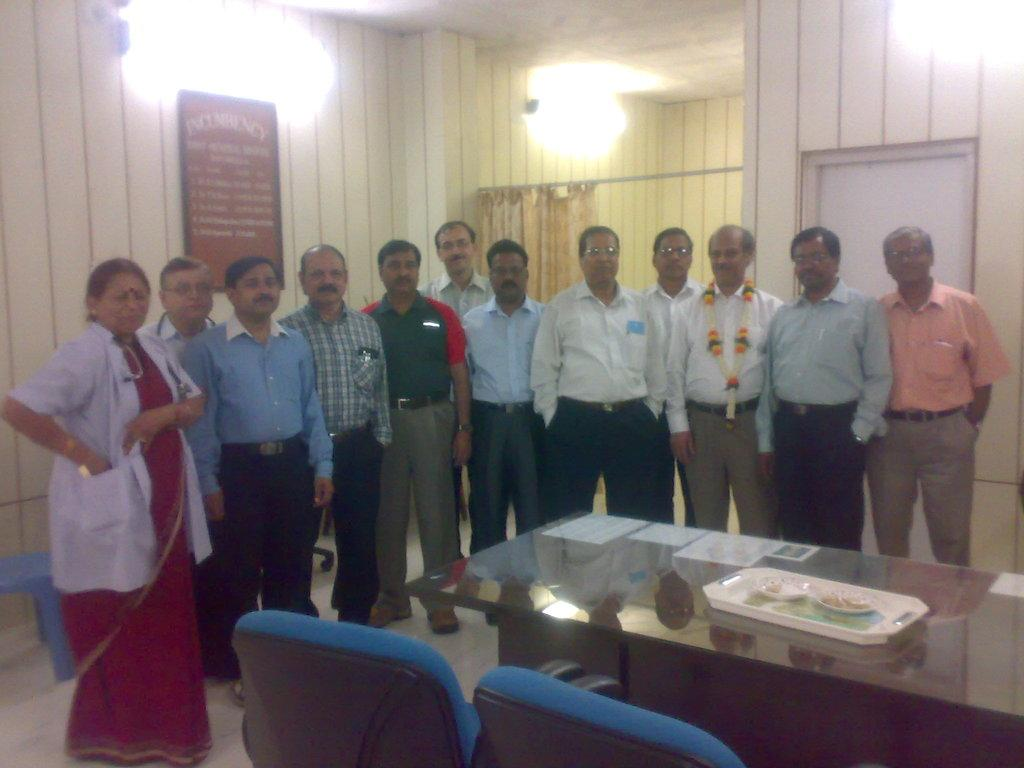How many people are in the image? There are persons standing in the image. What furniture is present in the image? There is a table and chairs in the image. What is on the table in the image? There is a tray on the table. What is on the tray in the image? There is food on the tray. What can be seen in the background of the image? There is a wall, a board, and lights in the background of the image. What type of line can be seen on the ground in the image? There is no line on the ground in the image. How does the board in the background of the image provide care for the persons in the image? The board in the background of the image does not provide care for the persons in the image; it is simply a part of the background. 